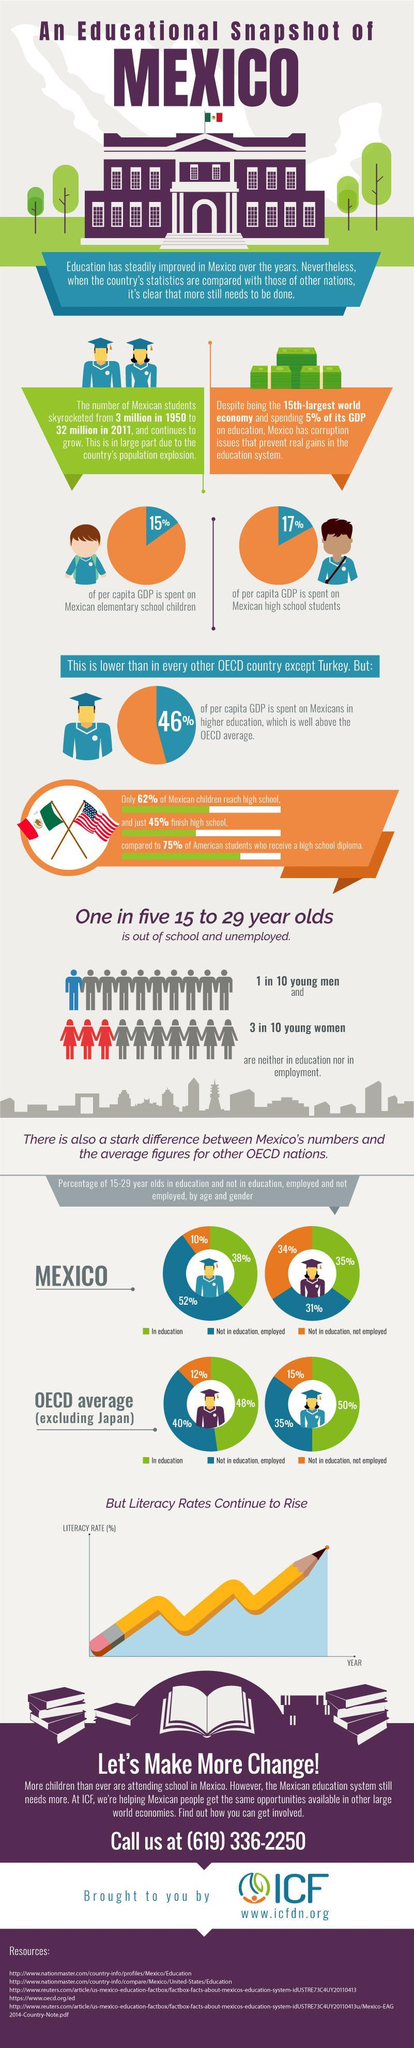What is the % difference in percapita GDP spend on elementary and high school students
Answer the question with a short phrase. 2 the per capita GDP spent on Mexicans higher education is higher than which other country Turkey What is the increase in the number of students in millions from 1950 to 2011 29 what percentage of people in the15 to 29 year range is out of school and unemployed 20 Which country has the second lowest spend on per capital GDP in higher education among all OECD countries Mexico How many % of females in Mexico are not in education, but either employed or not employed 65 How many % of males in Mexico are not in education, but either employed or not employed 62 What is the major challenge in the education system for Mexico corruption issues 